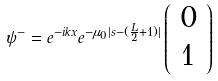<formula> <loc_0><loc_0><loc_500><loc_500>\psi ^ { - } = e ^ { - i k x } e ^ { - \mu _ { 0 } | s - ( \frac { L } { 2 } + 1 ) | } \left ( \begin{array} { l } 0 \\ 1 \end{array} \right )</formula> 